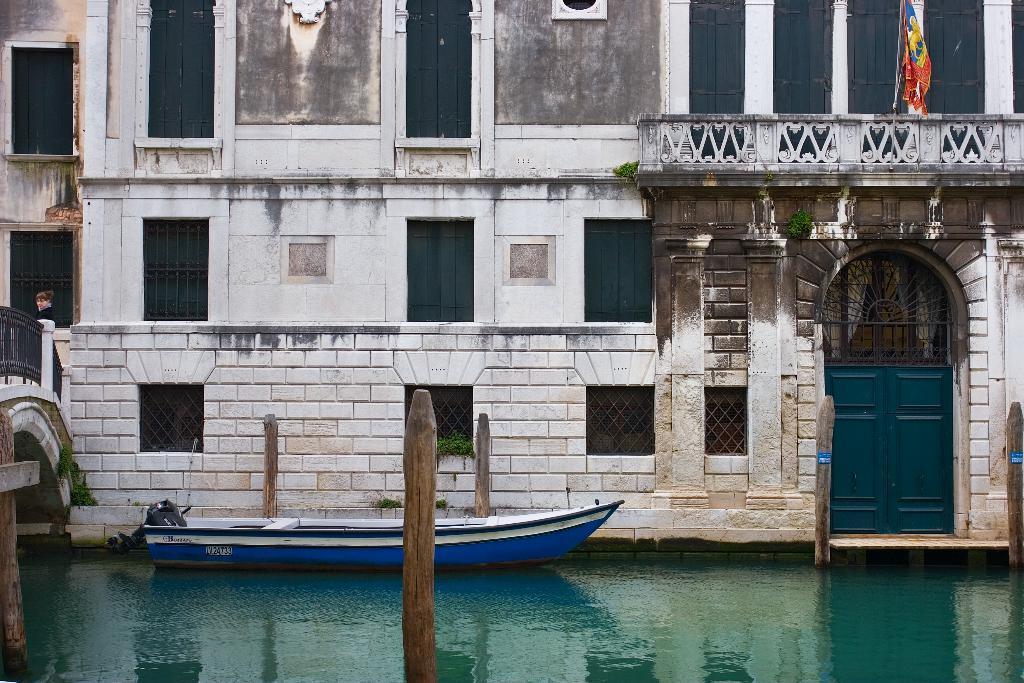Please provide a concise description of this image. In this image we can see a building with windows, railing and doors. Also there is a flag with a pole. And we can see boat on the water. And there are wooden poles. On the right side there is a bridge with railing. 